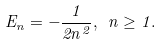<formula> <loc_0><loc_0><loc_500><loc_500>E _ { n } = - \frac { 1 } { 2 n ^ { 2 } } , \ n \geq 1 .</formula> 